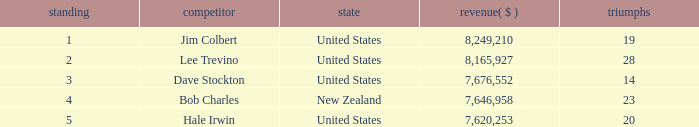How many players named bob charles with earnings over $7,646,958? 0.0. 